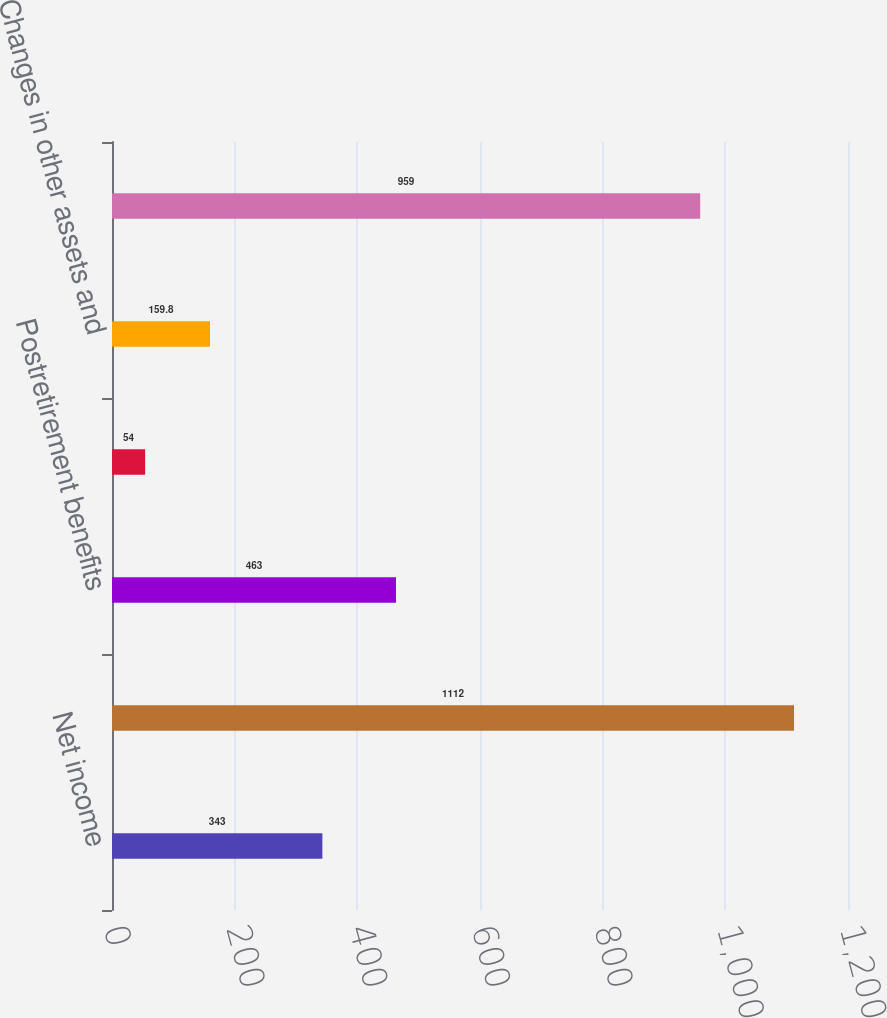Convert chart to OTSL. <chart><loc_0><loc_0><loc_500><loc_500><bar_chart><fcel>Net income<fcel>Non-cash transactions 1<fcel>Postretirement benefits<fcel>Changes in core working<fcel>Changes in other assets and<fcel>Net cash provided by operating<nl><fcel>343<fcel>1112<fcel>463<fcel>54<fcel>159.8<fcel>959<nl></chart> 